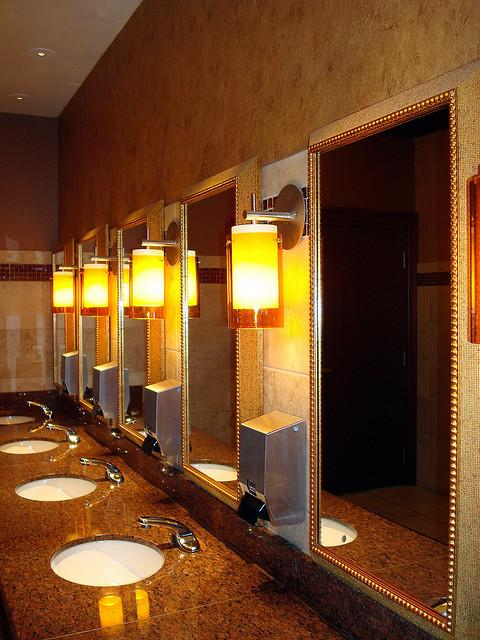What are the metal boxes on the wall used for? Please explain your reasoning. soap dispenser. The lever on these boxes and their placement at each sink in the image tell us they dispense soap. 